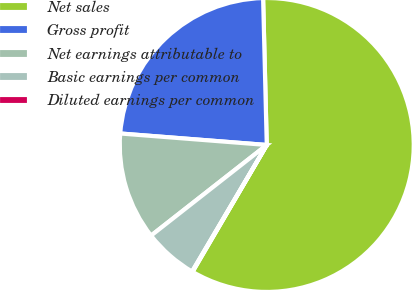<chart> <loc_0><loc_0><loc_500><loc_500><pie_chart><fcel>Net sales<fcel>Gross profit<fcel>Net earnings attributable to<fcel>Basic earnings per common<fcel>Diluted earnings per common<nl><fcel>58.82%<fcel>23.36%<fcel>11.82%<fcel>5.94%<fcel>0.06%<nl></chart> 